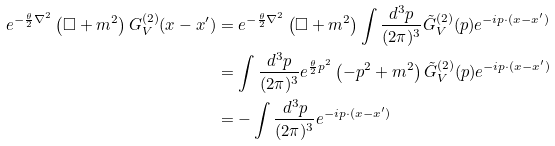<formula> <loc_0><loc_0><loc_500><loc_500>e ^ { - \frac { \theta } { 2 } \nabla ^ { 2 } } \left ( \Box + m ^ { 2 } \right ) G _ { V } ^ { ( 2 ) } ( x - x ^ { \prime } ) & = e ^ { - \frac { \theta } { 2 } \nabla ^ { 2 } } \left ( \Box + m ^ { 2 } \right ) \int \frac { d ^ { 3 } p } { ( 2 \pi ) ^ { 3 } } \tilde { G } _ { V } ^ { ( 2 ) } ( p ) e ^ { - i p \cdot ( x - x ^ { \prime } ) } \\ & = \int \frac { d ^ { 3 } p } { ( 2 \pi ) ^ { 3 } } e ^ { \frac { \theta } { 2 } p ^ { 2 } } \left ( - p ^ { 2 } + m ^ { 2 } \right ) \tilde { G } _ { V } ^ { ( 2 ) } ( p ) e ^ { - i p \cdot ( x - x ^ { \prime } ) } \\ & = - \int \frac { d ^ { 3 } p } { ( 2 \pi ) ^ { 3 } } e ^ { - i p \cdot ( x - x ^ { \prime } ) }</formula> 